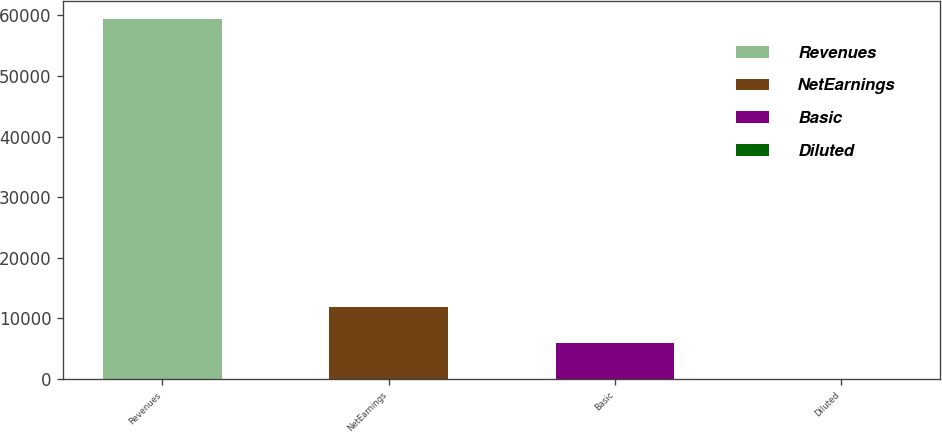<chart> <loc_0><loc_0><loc_500><loc_500><bar_chart><fcel>Revenues<fcel>NetEarnings<fcel>Basic<fcel>Diluted<nl><fcel>59426<fcel>11887.2<fcel>5944.83<fcel>2.48<nl></chart> 